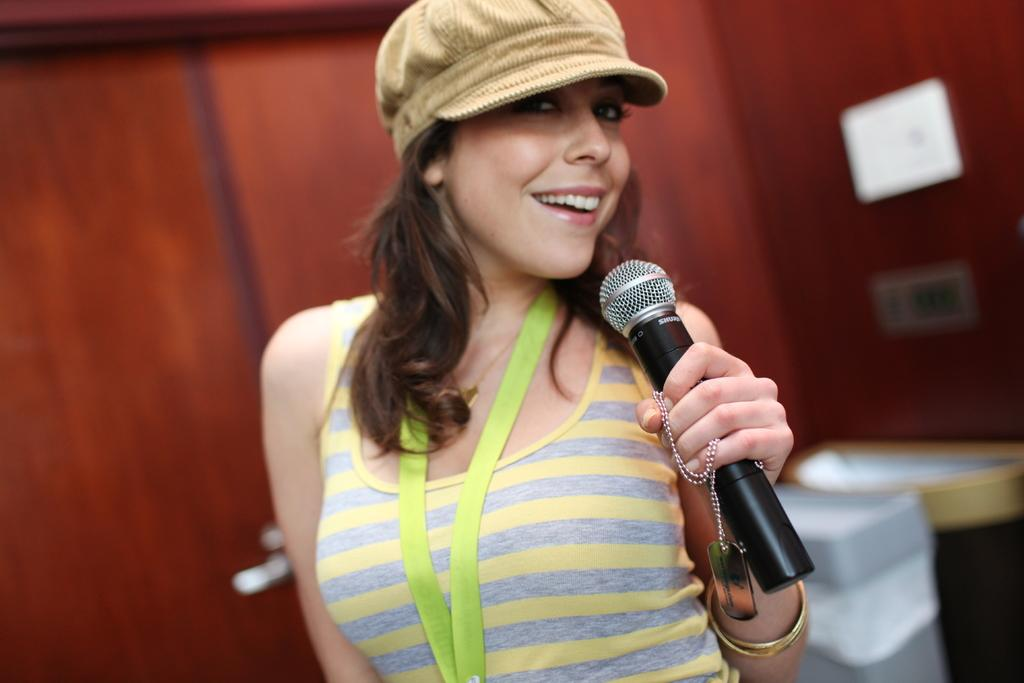Who is the main subject in the image? There is a woman in the image. What is the woman doing in the image? The woman is standing and holding a microphone in her hand. What is the woman's facial expression in the image? The woman is smiling in the image. What is the woman wearing in the image? The woman is wearing an ID card in the image. What can be seen in the background of the image? There is a wall in the background of the image. How does the woman care for her leg in the image? There is no indication in the image that the woman is caring for her leg, as she is standing and holding a microphone. 